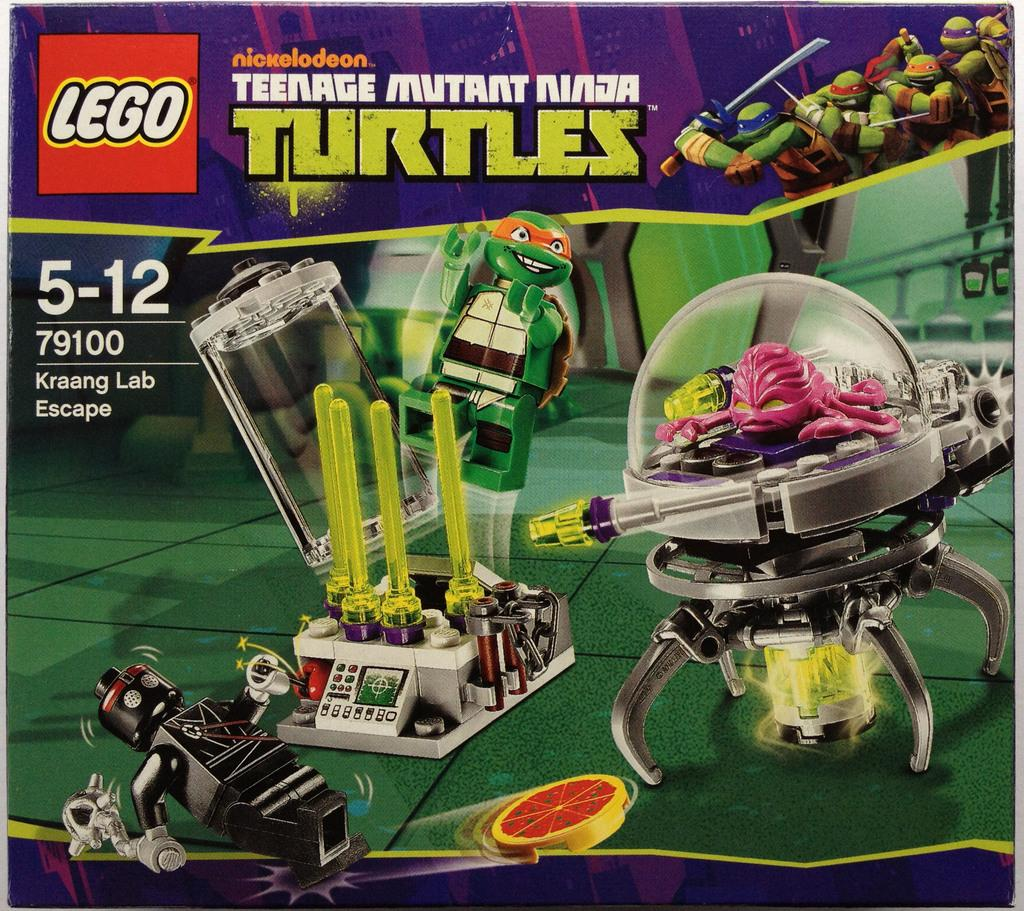<image>
Relay a brief, clear account of the picture shown. The Lego company has partnered with Nickelodeon to bring you a Teenage Mutant Ninja Turtles play set. 